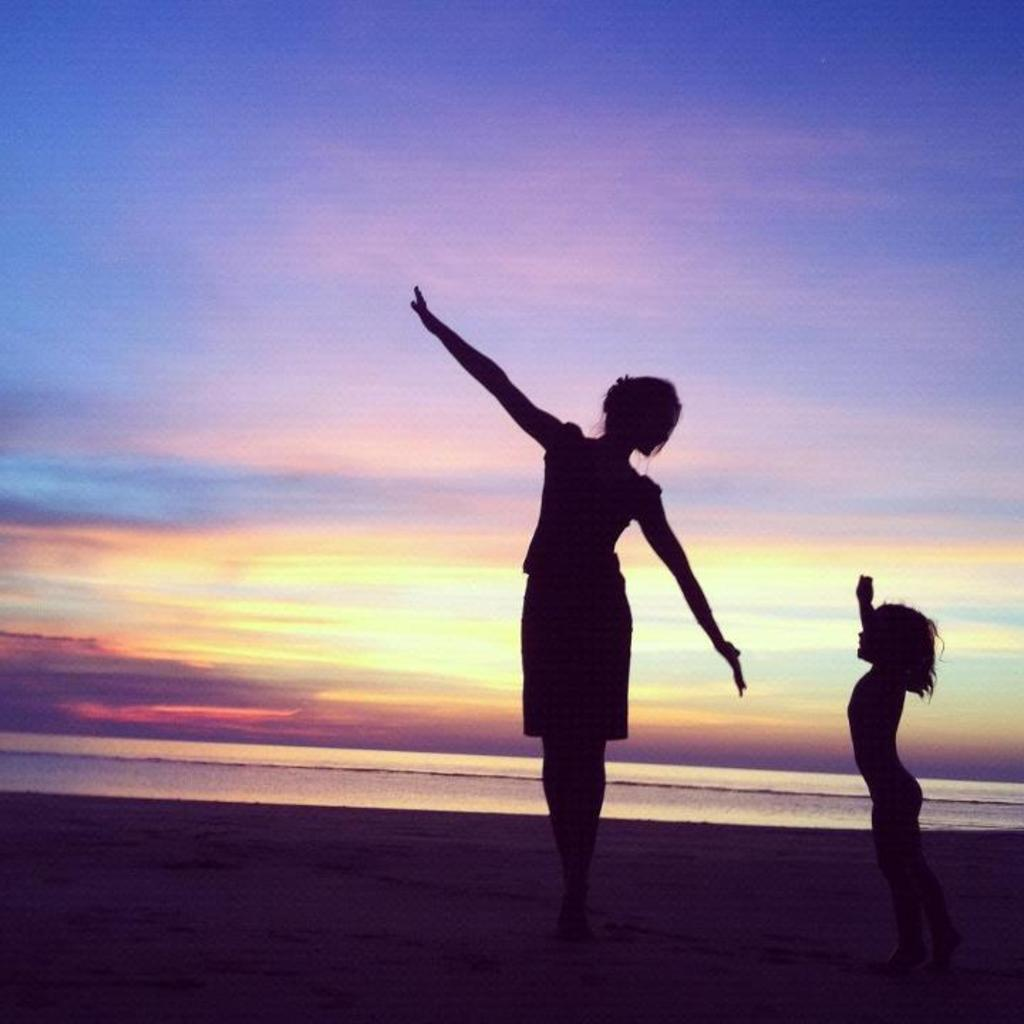Who is present in the image? There is a lady and a kid in the image. What are the lady and the kid doing in the image? The lady and the kid are standing. What can be seen in the background of the image? Water and the sky are visible in the background of the image. What type of coil is being used by the lady to teach the kid in the image? There is no coil present in the image, nor is there any indication that the lady is teaching the kid. 